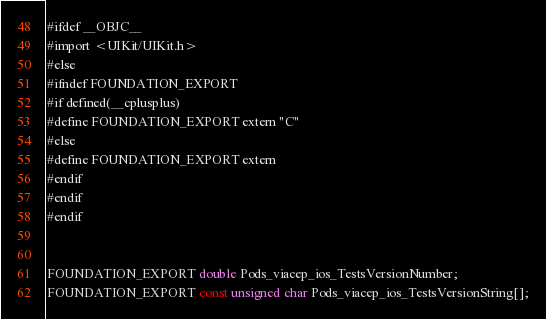<code> <loc_0><loc_0><loc_500><loc_500><_C_>#ifdef __OBJC__
#import <UIKit/UIKit.h>
#else
#ifndef FOUNDATION_EXPORT
#if defined(__cplusplus)
#define FOUNDATION_EXPORT extern "C"
#else
#define FOUNDATION_EXPORT extern
#endif
#endif
#endif


FOUNDATION_EXPORT double Pods_viacep_ios_TestsVersionNumber;
FOUNDATION_EXPORT const unsigned char Pods_viacep_ios_TestsVersionString[];

</code> 